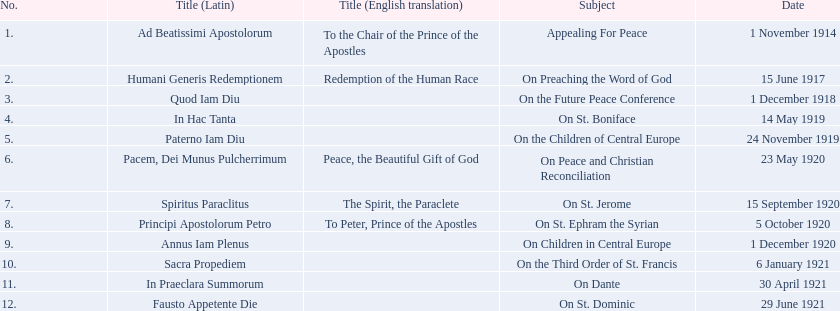What are all the subjects? Appealing For Peace, On Preaching the Word of God, On the Future Peace Conference, On St. Boniface, On the Children of Central Europe, On Peace and Christian Reconciliation, On St. Jerome, On St. Ephram the Syrian, On Children in Central Europe, On the Third Order of St. Francis, On Dante, On St. Dominic. What are their dates? 1 November 1914, 15 June 1917, 1 December 1918, 14 May 1919, 24 November 1919, 23 May 1920, 15 September 1920, 5 October 1920, 1 December 1920, 6 January 1921, 30 April 1921, 29 June 1921. Which subject's date belongs to 23 may 1920? On Peace and Christian Reconciliation. 